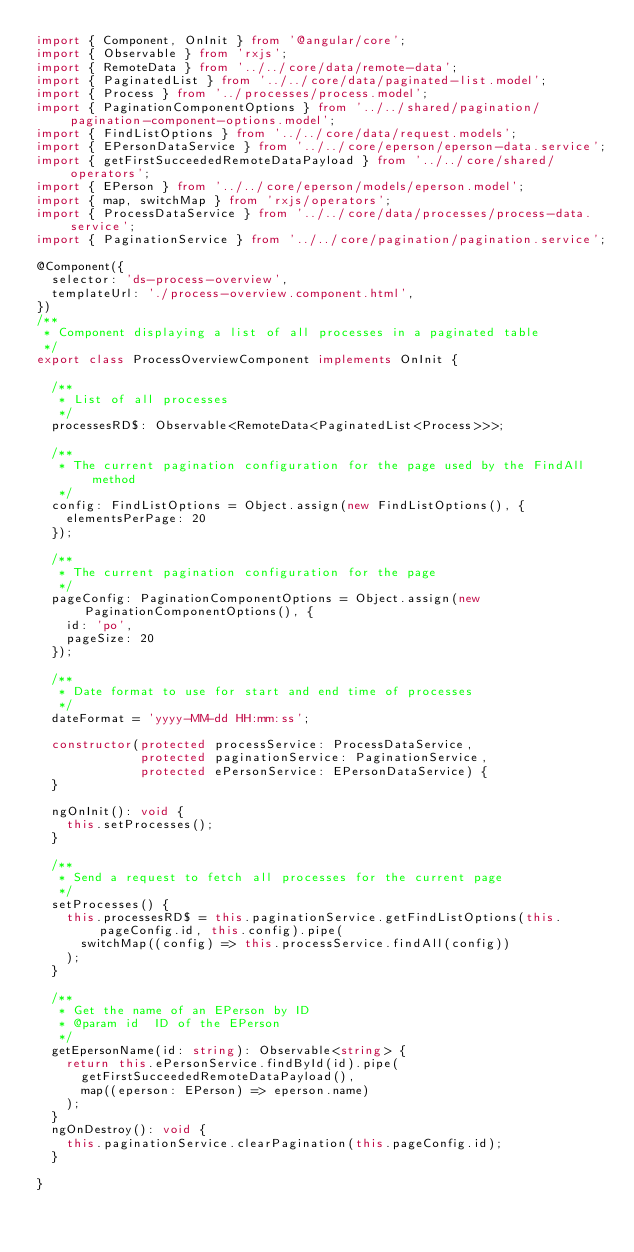Convert code to text. <code><loc_0><loc_0><loc_500><loc_500><_TypeScript_>import { Component, OnInit } from '@angular/core';
import { Observable } from 'rxjs';
import { RemoteData } from '../../core/data/remote-data';
import { PaginatedList } from '../../core/data/paginated-list.model';
import { Process } from '../processes/process.model';
import { PaginationComponentOptions } from '../../shared/pagination/pagination-component-options.model';
import { FindListOptions } from '../../core/data/request.models';
import { EPersonDataService } from '../../core/eperson/eperson-data.service';
import { getFirstSucceededRemoteDataPayload } from '../../core/shared/operators';
import { EPerson } from '../../core/eperson/models/eperson.model';
import { map, switchMap } from 'rxjs/operators';
import { ProcessDataService } from '../../core/data/processes/process-data.service';
import { PaginationService } from '../../core/pagination/pagination.service';

@Component({
  selector: 'ds-process-overview',
  templateUrl: './process-overview.component.html',
})
/**
 * Component displaying a list of all processes in a paginated table
 */
export class ProcessOverviewComponent implements OnInit {

  /**
   * List of all processes
   */
  processesRD$: Observable<RemoteData<PaginatedList<Process>>>;

  /**
   * The current pagination configuration for the page used by the FindAll method
   */
  config: FindListOptions = Object.assign(new FindListOptions(), {
    elementsPerPage: 20
  });

  /**
   * The current pagination configuration for the page
   */
  pageConfig: PaginationComponentOptions = Object.assign(new PaginationComponentOptions(), {
    id: 'po',
    pageSize: 20
  });

  /**
   * Date format to use for start and end time of processes
   */
  dateFormat = 'yyyy-MM-dd HH:mm:ss';

  constructor(protected processService: ProcessDataService,
              protected paginationService: PaginationService,
              protected ePersonService: EPersonDataService) {
  }

  ngOnInit(): void {
    this.setProcesses();
  }

  /**
   * Send a request to fetch all processes for the current page
   */
  setProcesses() {
    this.processesRD$ = this.paginationService.getFindListOptions(this.pageConfig.id, this.config).pipe(
      switchMap((config) => this.processService.findAll(config))
    );
  }

  /**
   * Get the name of an EPerson by ID
   * @param id  ID of the EPerson
   */
  getEpersonName(id: string): Observable<string> {
    return this.ePersonService.findById(id).pipe(
      getFirstSucceededRemoteDataPayload(),
      map((eperson: EPerson) => eperson.name)
    );
  }
  ngOnDestroy(): void {
    this.paginationService.clearPagination(this.pageConfig.id);
  }

}
</code> 